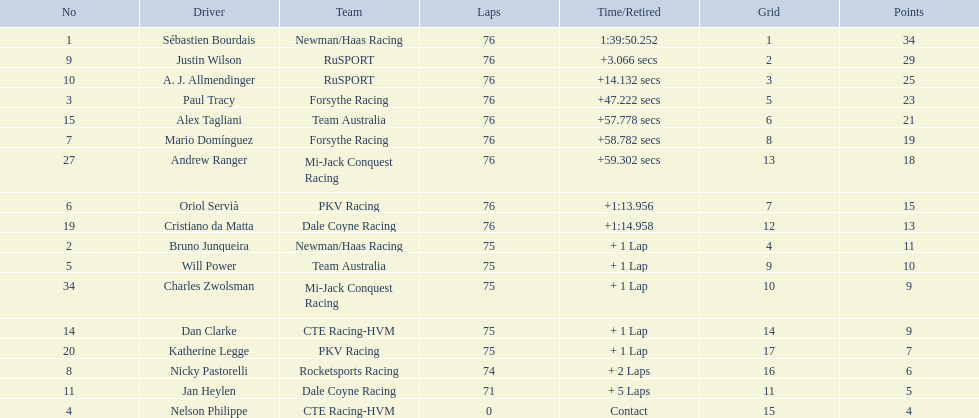Which drivers completed all 76 laps? Sébastien Bourdais, Justin Wilson, A. J. Allmendinger, Paul Tracy, Alex Tagliani, Mario Domínguez, Andrew Ranger, Oriol Servià, Cristiano da Matta. Of these drivers, which ones finished less than a minute behind first place? Paul Tracy, Alex Tagliani, Mario Domínguez, Andrew Ranger. Of these drivers, which ones finished with a time less than 50 seconds behind first place? Justin Wilson, A. J. Allmendinger, Paul Tracy. Of these three drivers, who finished last? Paul Tracy. 